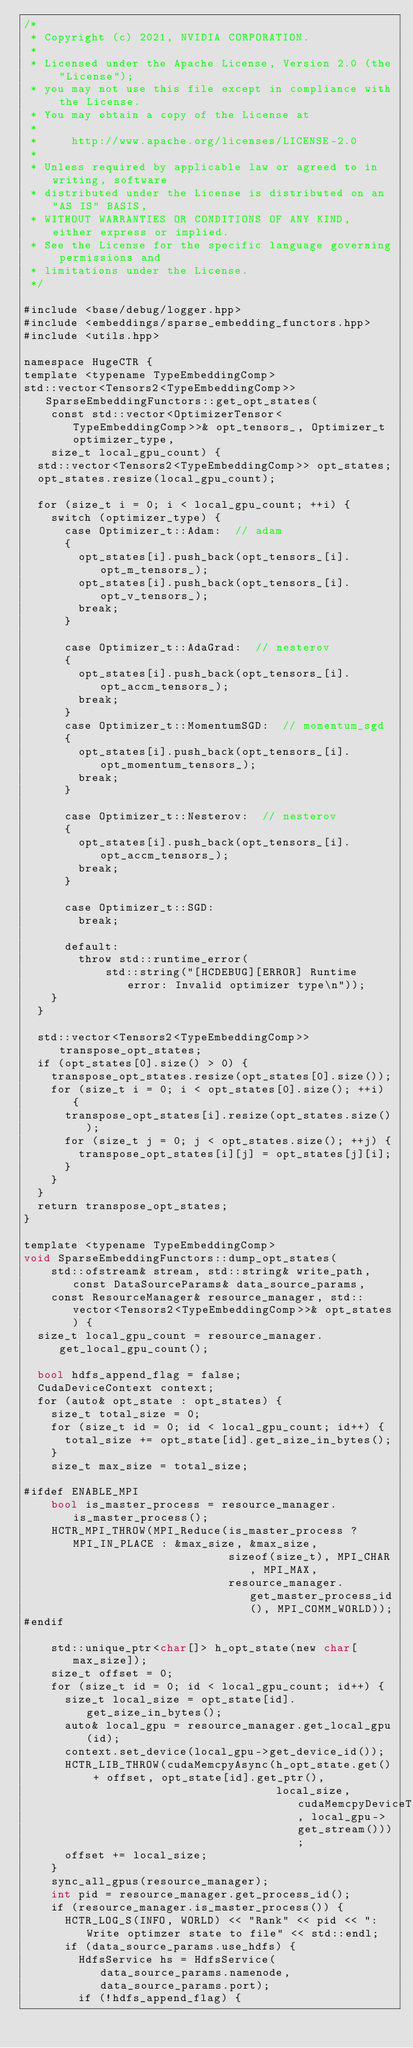<code> <loc_0><loc_0><loc_500><loc_500><_Cuda_>/*
 * Copyright (c) 2021, NVIDIA CORPORATION.
 *
 * Licensed under the Apache License, Version 2.0 (the "License");
 * you may not use this file except in compliance with the License.
 * You may obtain a copy of the License at
 *
 *     http://www.apache.org/licenses/LICENSE-2.0
 *
 * Unless required by applicable law or agreed to in writing, software
 * distributed under the License is distributed on an "AS IS" BASIS,
 * WITHOUT WARRANTIES OR CONDITIONS OF ANY KIND, either express or implied.
 * See the License for the specific language governing permissions and
 * limitations under the License.
 */

#include <base/debug/logger.hpp>
#include <embeddings/sparse_embedding_functors.hpp>
#include <utils.hpp>

namespace HugeCTR {
template <typename TypeEmbeddingComp>
std::vector<Tensors2<TypeEmbeddingComp>> SparseEmbeddingFunctors::get_opt_states(
    const std::vector<OptimizerTensor<TypeEmbeddingComp>>& opt_tensors_, Optimizer_t optimizer_type,
    size_t local_gpu_count) {
  std::vector<Tensors2<TypeEmbeddingComp>> opt_states;
  opt_states.resize(local_gpu_count);

  for (size_t i = 0; i < local_gpu_count; ++i) {
    switch (optimizer_type) {
      case Optimizer_t::Adam:  // adam
      {
        opt_states[i].push_back(opt_tensors_[i].opt_m_tensors_);
        opt_states[i].push_back(opt_tensors_[i].opt_v_tensors_);
        break;
      }

      case Optimizer_t::AdaGrad:  // nesterov
      {
        opt_states[i].push_back(opt_tensors_[i].opt_accm_tensors_);
        break;
      }
      case Optimizer_t::MomentumSGD:  // momentum_sgd
      {
        opt_states[i].push_back(opt_tensors_[i].opt_momentum_tensors_);
        break;
      }

      case Optimizer_t::Nesterov:  // nesterov
      {
        opt_states[i].push_back(opt_tensors_[i].opt_accm_tensors_);
        break;
      }

      case Optimizer_t::SGD:
        break;

      default:
        throw std::runtime_error(
            std::string("[HCDEBUG][ERROR] Runtime error: Invalid optimizer type\n"));
    }
  }

  std::vector<Tensors2<TypeEmbeddingComp>> transpose_opt_states;
  if (opt_states[0].size() > 0) {
    transpose_opt_states.resize(opt_states[0].size());
    for (size_t i = 0; i < opt_states[0].size(); ++i) {
      transpose_opt_states[i].resize(opt_states.size());
      for (size_t j = 0; j < opt_states.size(); ++j) {
        transpose_opt_states[i][j] = opt_states[j][i];
      }
    }
  }
  return transpose_opt_states;
}

template <typename TypeEmbeddingComp>
void SparseEmbeddingFunctors::dump_opt_states(
    std::ofstream& stream, std::string& write_path, const DataSourceParams& data_source_params,
    const ResourceManager& resource_manager, std::vector<Tensors2<TypeEmbeddingComp>>& opt_states) {
  size_t local_gpu_count = resource_manager.get_local_gpu_count();

  bool hdfs_append_flag = false;
  CudaDeviceContext context;
  for (auto& opt_state : opt_states) {
    size_t total_size = 0;
    for (size_t id = 0; id < local_gpu_count; id++) {
      total_size += opt_state[id].get_size_in_bytes();
    }
    size_t max_size = total_size;

#ifdef ENABLE_MPI
    bool is_master_process = resource_manager.is_master_process();
    HCTR_MPI_THROW(MPI_Reduce(is_master_process ? MPI_IN_PLACE : &max_size, &max_size,
                              sizeof(size_t), MPI_CHAR, MPI_MAX,
                              resource_manager.get_master_process_id(), MPI_COMM_WORLD));
#endif

    std::unique_ptr<char[]> h_opt_state(new char[max_size]);
    size_t offset = 0;
    for (size_t id = 0; id < local_gpu_count; id++) {
      size_t local_size = opt_state[id].get_size_in_bytes();
      auto& local_gpu = resource_manager.get_local_gpu(id);
      context.set_device(local_gpu->get_device_id());
      HCTR_LIB_THROW(cudaMemcpyAsync(h_opt_state.get() + offset, opt_state[id].get_ptr(),
                                     local_size, cudaMemcpyDeviceToHost, local_gpu->get_stream()));
      offset += local_size;
    }
    sync_all_gpus(resource_manager);
    int pid = resource_manager.get_process_id();
    if (resource_manager.is_master_process()) {
      HCTR_LOG_S(INFO, WORLD) << "Rank" << pid << ": Write optimzer state to file" << std::endl;
      if (data_source_params.use_hdfs) {
        HdfsService hs = HdfsService(data_source_params.namenode, data_source_params.port);
        if (!hdfs_append_flag) {</code> 